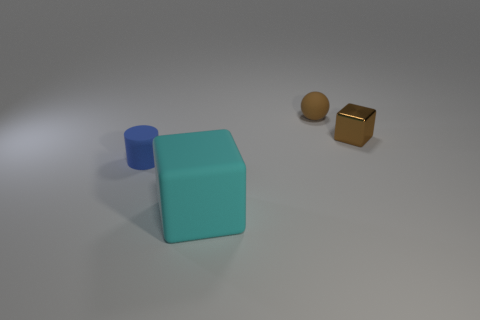Add 1 shiny blocks. How many objects exist? 5 Subtract all cylinders. How many objects are left? 3 Subtract 0 red cubes. How many objects are left? 4 Subtract all cyan spheres. Subtract all brown shiny objects. How many objects are left? 3 Add 3 small blue matte objects. How many small blue matte objects are left? 4 Add 4 red shiny cylinders. How many red shiny cylinders exist? 4 